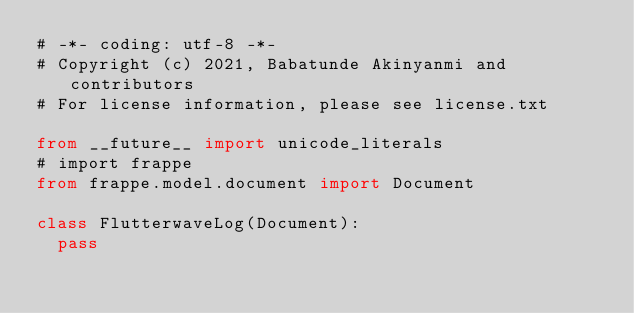Convert code to text. <code><loc_0><loc_0><loc_500><loc_500><_Python_># -*- coding: utf-8 -*-
# Copyright (c) 2021, Babatunde Akinyanmi and contributors
# For license information, please see license.txt

from __future__ import unicode_literals
# import frappe
from frappe.model.document import Document

class FlutterwaveLog(Document):
	pass
</code> 